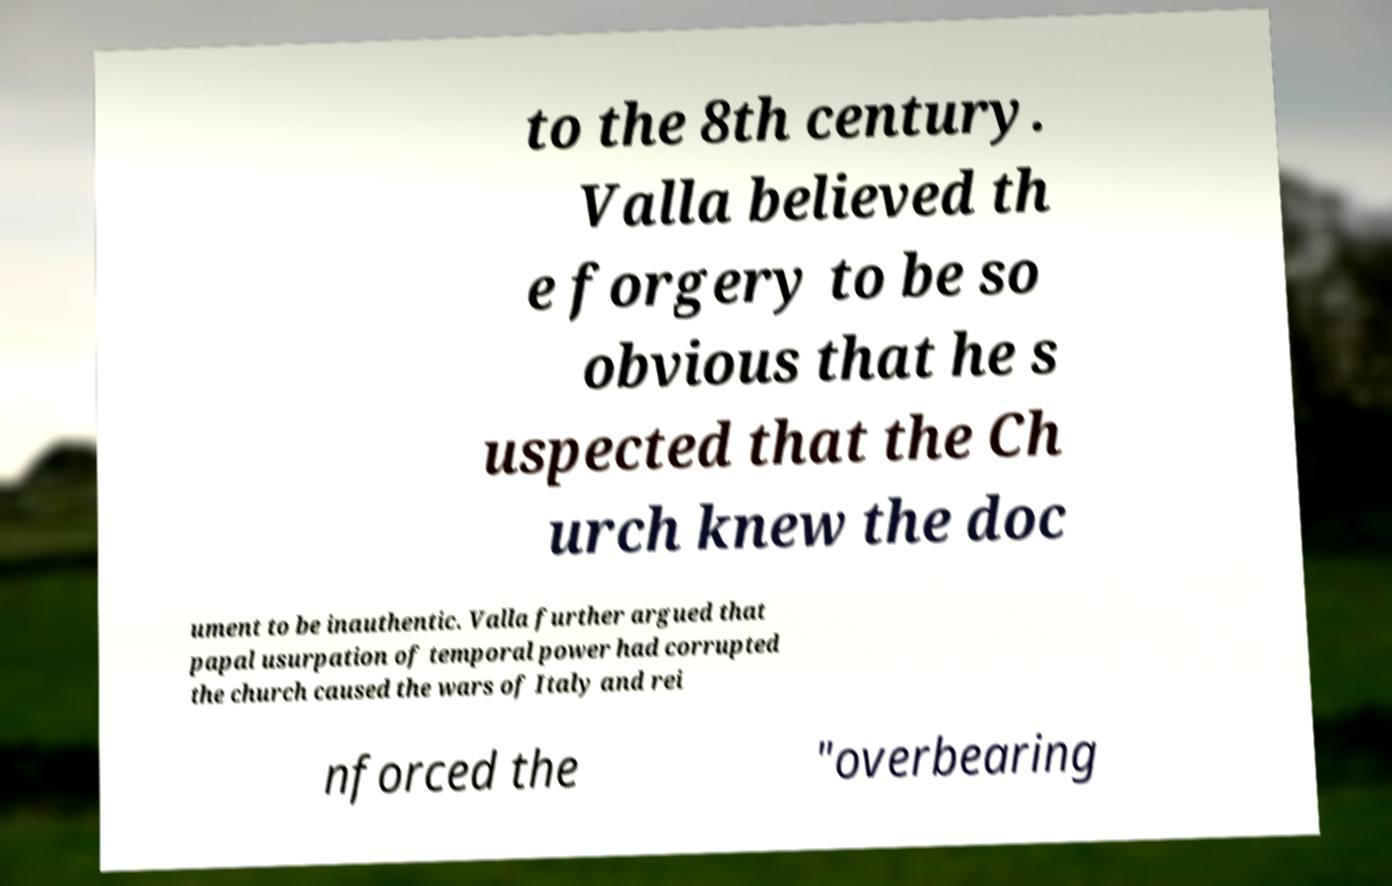I need the written content from this picture converted into text. Can you do that? to the 8th century. Valla believed th e forgery to be so obvious that he s uspected that the Ch urch knew the doc ument to be inauthentic. Valla further argued that papal usurpation of temporal power had corrupted the church caused the wars of Italy and rei nforced the "overbearing 